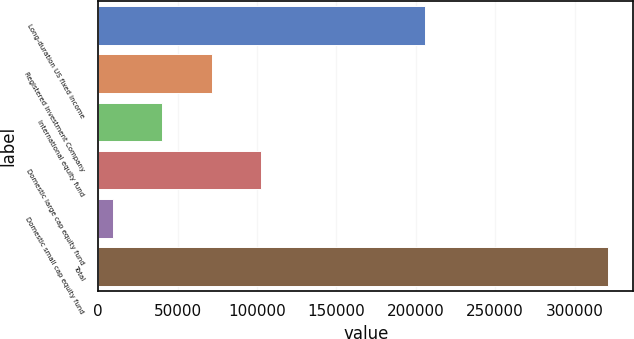Convert chart to OTSL. <chart><loc_0><loc_0><loc_500><loc_500><bar_chart><fcel>Long-duration US fixed income<fcel>Registered Investment Company<fcel>International equity fund<fcel>Domestic large cap equity fund<fcel>Domestic small cap equity fund<fcel>Total<nl><fcel>205695<fcel>71563.2<fcel>40385.1<fcel>102741<fcel>9207<fcel>320988<nl></chart> 